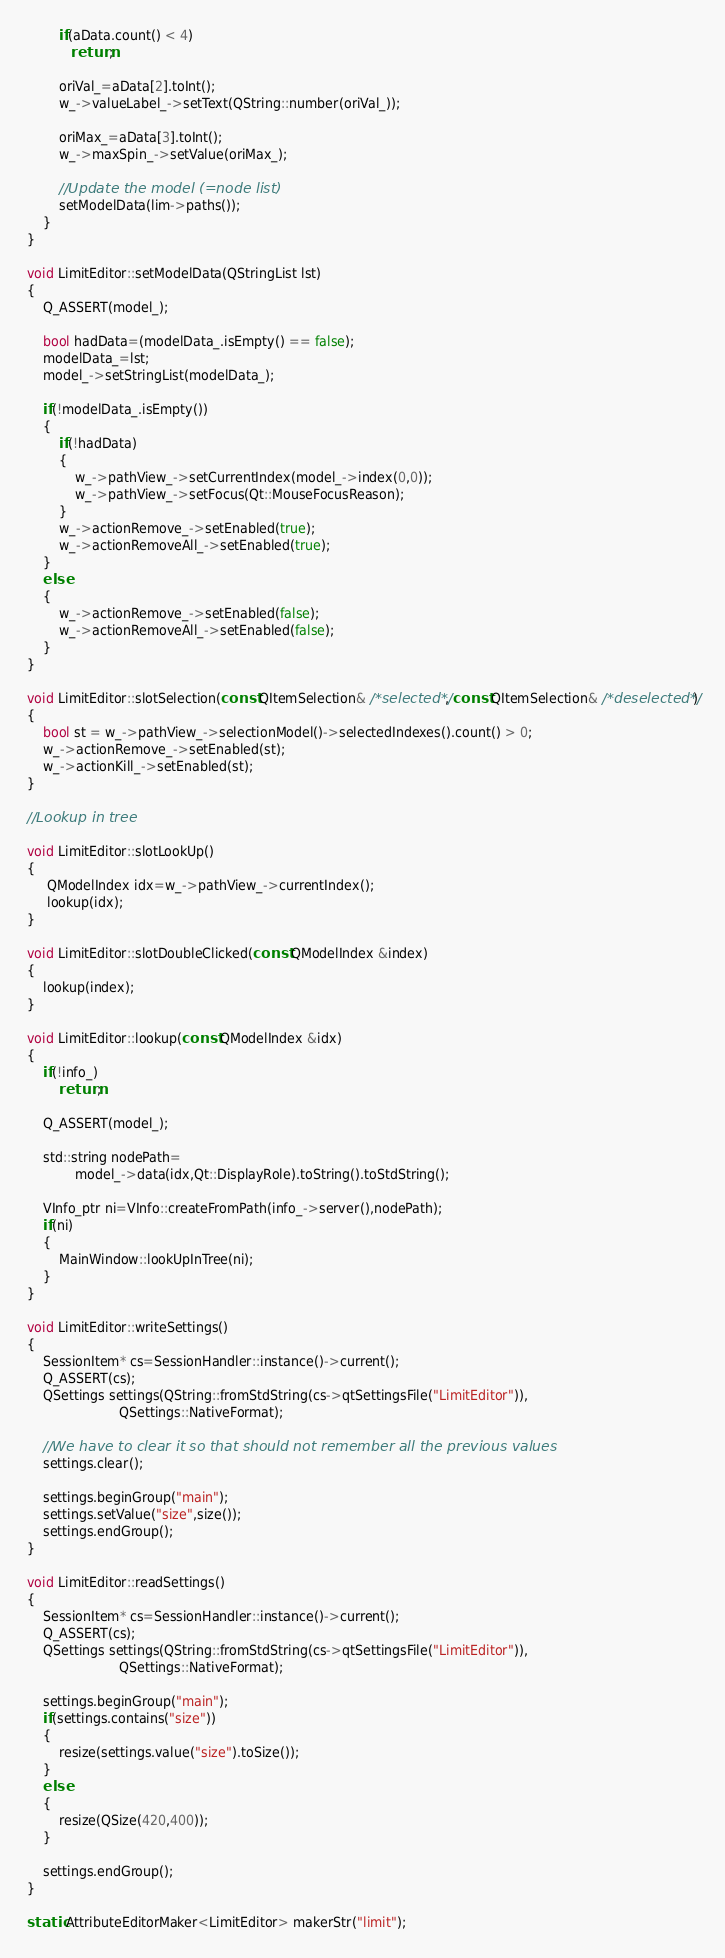<code> <loc_0><loc_0><loc_500><loc_500><_C++_>        if(aData.count() < 4)
           return;

        oriVal_=aData[2].toInt();
        w_->valueLabel_->setText(QString::number(oriVal_));

        oriMax_=aData[3].toInt();
        w_->maxSpin_->setValue(oriMax_);

        //Update the model (=node list)
        setModelData(lim->paths());
    }
}

void LimitEditor::setModelData(QStringList lst)
{
    Q_ASSERT(model_);

    bool hadData=(modelData_.isEmpty() == false);
    modelData_=lst;
    model_->setStringList(modelData_);

    if(!modelData_.isEmpty())
    {
        if(!hadData)
        {
            w_->pathView_->setCurrentIndex(model_->index(0,0));
            w_->pathView_->setFocus(Qt::MouseFocusReason);
        }
        w_->actionRemove_->setEnabled(true);
        w_->actionRemoveAll_->setEnabled(true);
    }
    else
    {
        w_->actionRemove_->setEnabled(false);
        w_->actionRemoveAll_->setEnabled(false);
    }
}

void LimitEditor::slotSelection(const QItemSelection& /*selected*/, const QItemSelection& /*deselected*/)
{
    bool st = w_->pathView_->selectionModel()->selectedIndexes().count() > 0;
    w_->actionRemove_->setEnabled(st);
    w_->actionKill_->setEnabled(st);
}

//Lookup in tree

void LimitEditor::slotLookUp()
{
     QModelIndex idx=w_->pathView_->currentIndex();
     lookup(idx);
}

void LimitEditor::slotDoubleClicked(const QModelIndex &index)
{
    lookup(index);
}

void LimitEditor::lookup(const QModelIndex &idx)
{
    if(!info_)
        return;

    Q_ASSERT(model_);

    std::string nodePath=
            model_->data(idx,Qt::DisplayRole).toString().toStdString();

    VInfo_ptr ni=VInfo::createFromPath(info_->server(),nodePath);
    if(ni)
    {
        MainWindow::lookUpInTree(ni);
    }
}

void LimitEditor::writeSettings()
{
    SessionItem* cs=SessionHandler::instance()->current();
    Q_ASSERT(cs);
    QSettings settings(QString::fromStdString(cs->qtSettingsFile("LimitEditor")),
                       QSettings::NativeFormat);

    //We have to clear it so that should not remember all the previous values
    settings.clear();

    settings.beginGroup("main");
    settings.setValue("size",size());
    settings.endGroup();
}

void LimitEditor::readSettings()
{
    SessionItem* cs=SessionHandler::instance()->current();
    Q_ASSERT(cs);
    QSettings settings(QString::fromStdString(cs->qtSettingsFile("LimitEditor")),
                       QSettings::NativeFormat);

    settings.beginGroup("main");
    if(settings.contains("size"))
    {
        resize(settings.value("size").toSize());
    }
    else
    {
        resize(QSize(420,400));
    }

    settings.endGroup();
}

static AttributeEditorMaker<LimitEditor> makerStr("limit");
</code> 